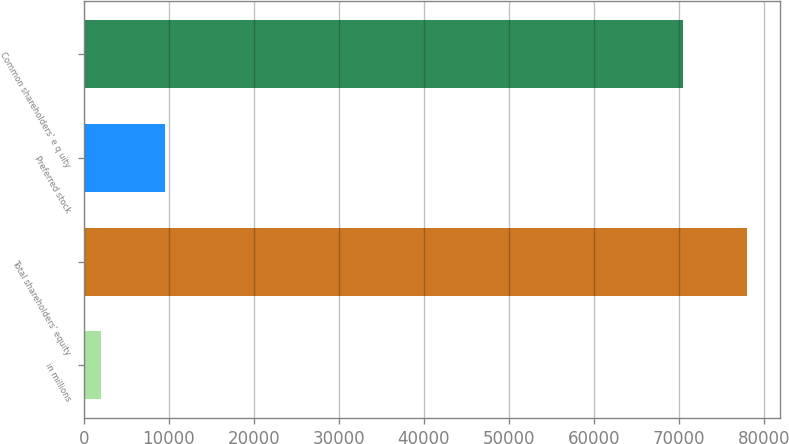Convert chart to OTSL. <chart><loc_0><loc_0><loc_500><loc_500><bar_chart><fcel>in millions<fcel>Total shareholders' equity<fcel>Preferred stock<fcel>Common shareholders' e q uity<nl><fcel>2013<fcel>77995<fcel>9547<fcel>70461<nl></chart> 